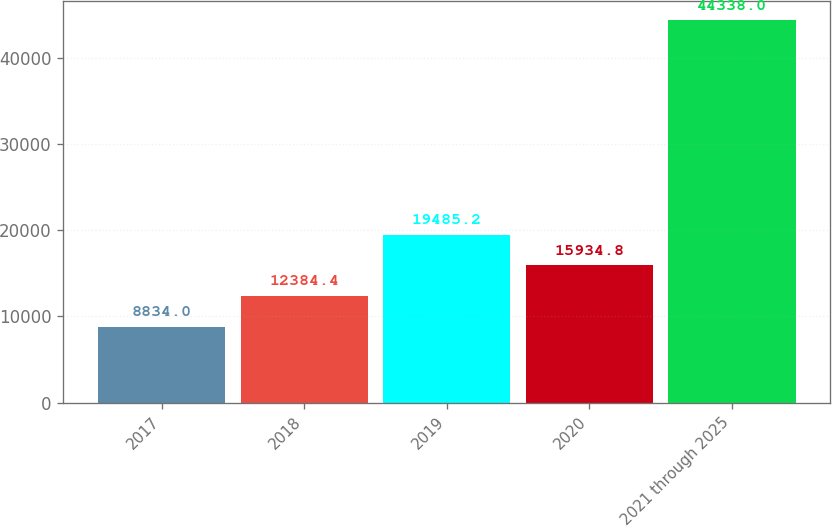Convert chart. <chart><loc_0><loc_0><loc_500><loc_500><bar_chart><fcel>2017<fcel>2018<fcel>2019<fcel>2020<fcel>2021 through 2025<nl><fcel>8834<fcel>12384.4<fcel>19485.2<fcel>15934.8<fcel>44338<nl></chart> 